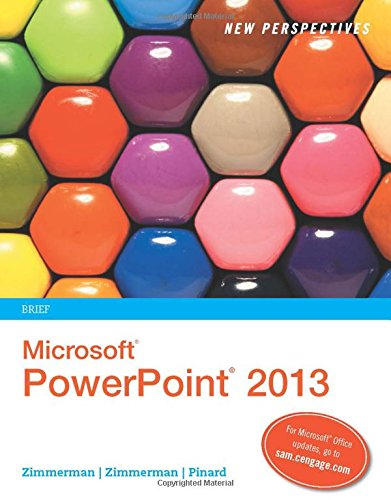What is the genre of this book? This book falls under the 'Computers & Technology' genre, specifically focusing on educational material for Microsoft PowerPoint 2013. 